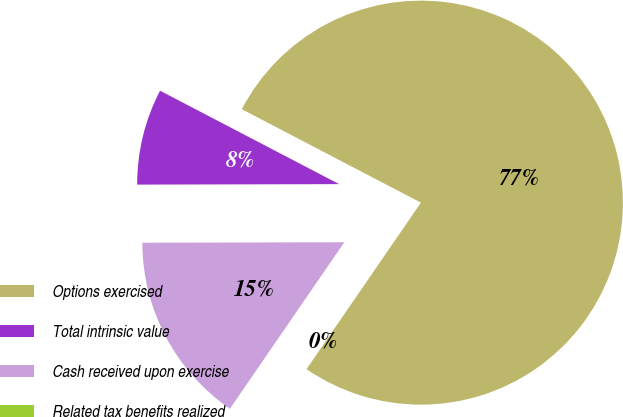<chart> <loc_0><loc_0><loc_500><loc_500><pie_chart><fcel>Options exercised<fcel>Total intrinsic value<fcel>Cash received upon exercise<fcel>Related tax benefits realized<nl><fcel>76.92%<fcel>7.69%<fcel>15.38%<fcel>0.0%<nl></chart> 